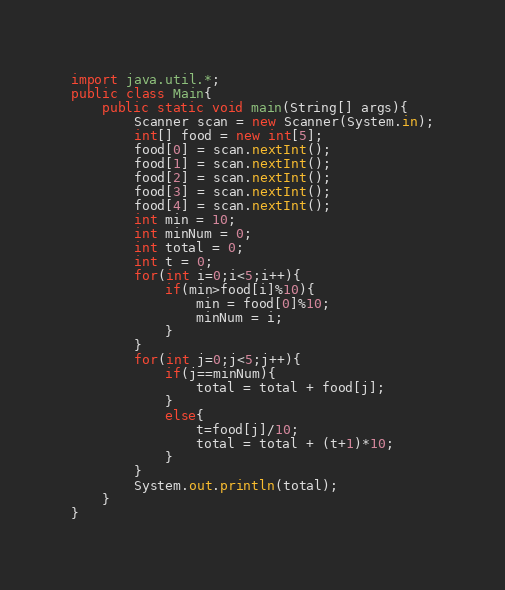Convert code to text. <code><loc_0><loc_0><loc_500><loc_500><_Java_>import java.util.*;
public class Main{
	public static void main(String[] args){
		Scanner scan = new Scanner(System.in);
		int[] food = new int[5];
		food[0] = scan.nextInt();
		food[1] = scan.nextInt();
		food[2] = scan.nextInt();
		food[3] = scan.nextInt();
		food[4] = scan.nextInt();
		int min = 10;
		int minNum = 0;
		int total = 0;
		int t = 0;
		for(int i=0;i<5;i++){
			if(min>food[i]%10){
				min = food[0]%10;
				minNum = i;
			}
		}
		for(int j=0;j<5;j++){
			if(j==minNum){
				total = total + food[j];
			}
			else{
				t=food[j]/10;
				total = total + (t+1)*10;
			}
		}
		System.out.println(total);
	}
}</code> 